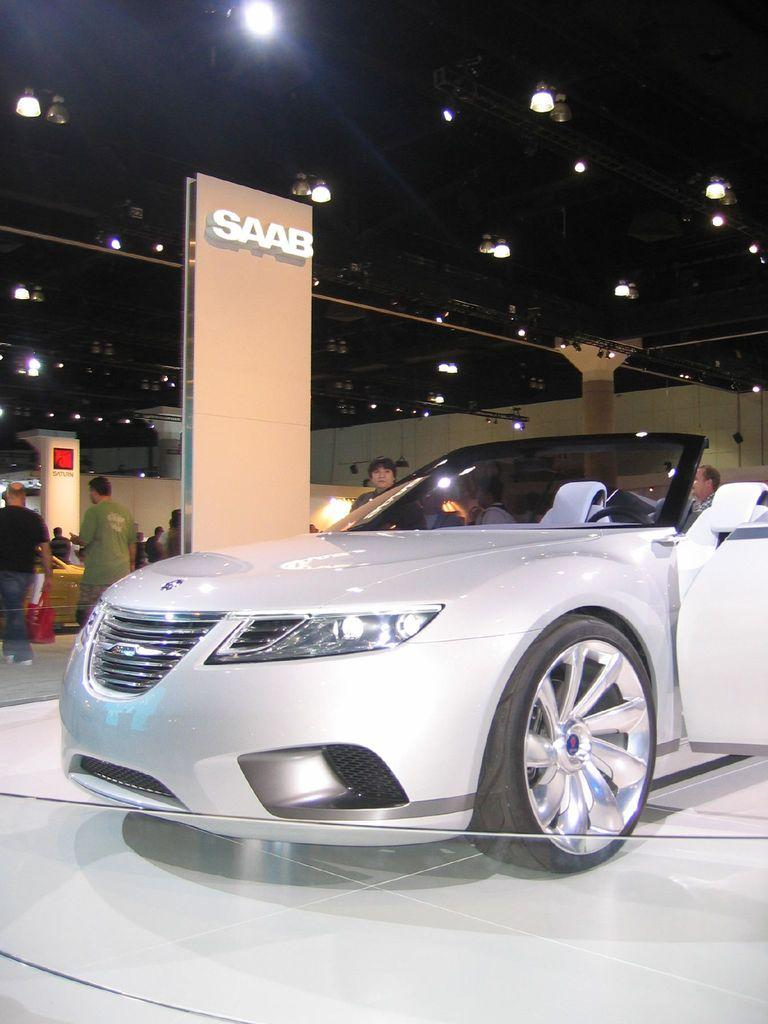What is the main subject of the image? There is a car in the showroom. What are the people in the image doing? The people are standing and watching the car. What can be seen on the ceiling in the showroom? There are lights on the ceiling in the showroom. What type of stone can be seen in the image? There is no stone present in the image; it features a car in a showroom with people watching and lights on the ceiling. How many oranges are visible in the image? There are no oranges present in the image. 